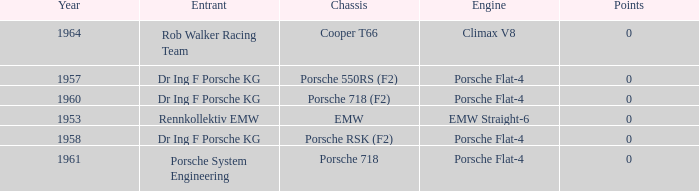Which engine did dr ing f porsche kg use with the porsche rsk (f2) chassis? Porsche Flat-4. 